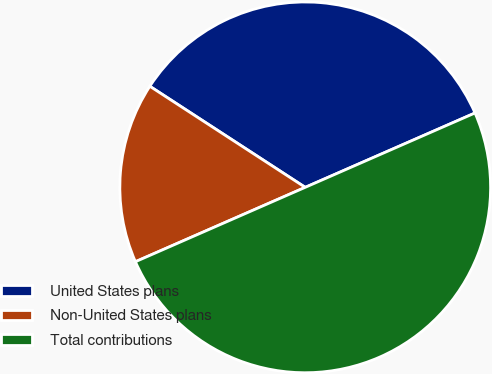<chart> <loc_0><loc_0><loc_500><loc_500><pie_chart><fcel>United States plans<fcel>Non-United States plans<fcel>Total contributions<nl><fcel>34.25%<fcel>15.75%<fcel>50.0%<nl></chart> 